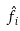<formula> <loc_0><loc_0><loc_500><loc_500>\hat { f } _ { i }</formula> 